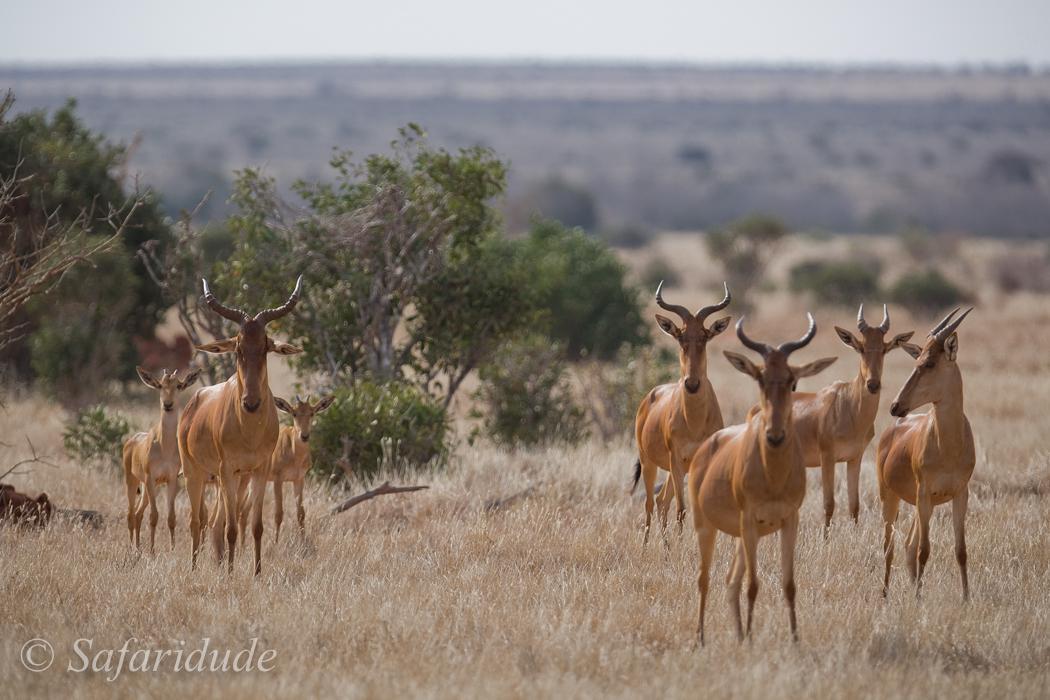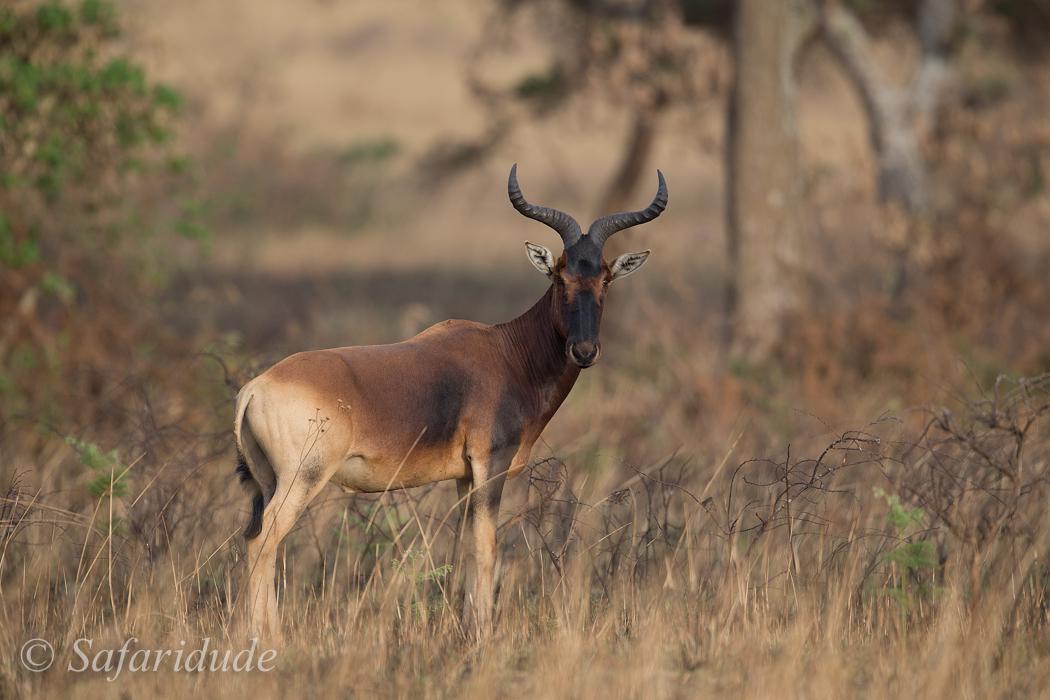The first image is the image on the left, the second image is the image on the right. For the images shown, is this caption "There are no more than three animals in the image on the right." true? Answer yes or no. Yes. The first image is the image on the left, the second image is the image on the right. Evaluate the accuracy of this statement regarding the images: "The right image contains no more than three antelope.". Is it true? Answer yes or no. Yes. 